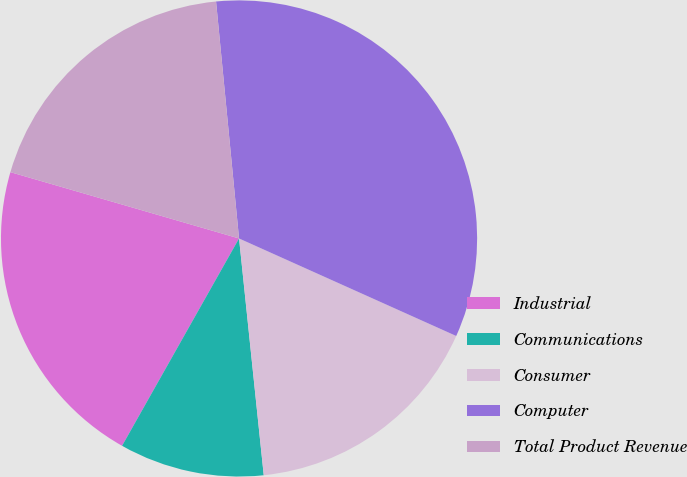Convert chart to OTSL. <chart><loc_0><loc_0><loc_500><loc_500><pie_chart><fcel>Industrial<fcel>Communications<fcel>Consumer<fcel>Computer<fcel>Total Product Revenue<nl><fcel>21.32%<fcel>9.83%<fcel>16.63%<fcel>33.26%<fcel>18.97%<nl></chart> 